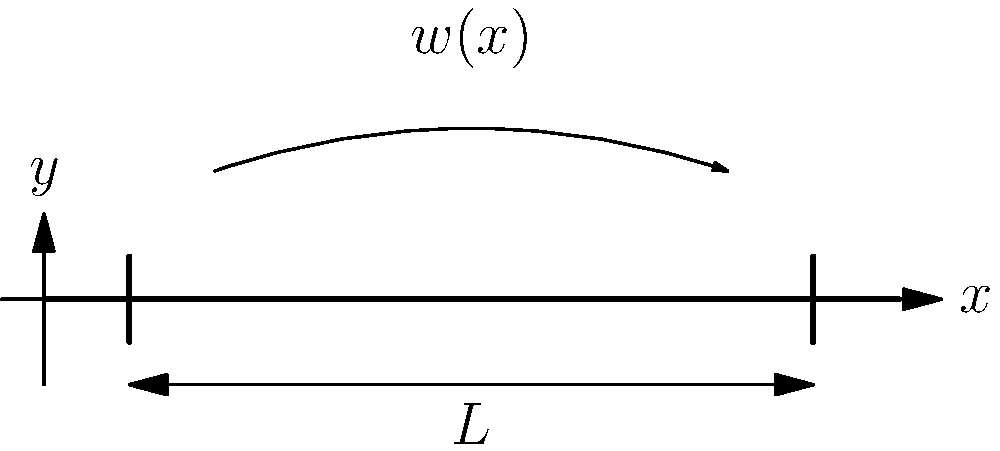A simply supported beam of length $L$ is subjected to a non-uniform distributed load $w(x)$ as shown in the figure. Given that the maximum bending moment occurs at the center of the beam, derive an expression for the shear force $V(x)$ at any point $x$ along the beam in terms of $w(x)$ and $L$. How does this relate to the stress distribution in the beam? To solve this problem, we'll follow these steps:

1) First, recall the relationship between distributed load $w(x)$, shear force $V(x)$, and bending moment $M(x)$:

   $$\frac{dV}{dx} = -w(x)$$
   $$\frac{dM}{dx} = V(x)$$

2) Given that the maximum bending moment occurs at the center of the beam, we know that the shear force at $x = L/2$ must be zero:

   $$V(L/2) = 0$$

3) We can express the shear force at any point $x$ as the integral of the distributed load from that point to the center of the beam:

   $$V(x) = \int_{x}^{L/2} w(t) dt$$

4) This expression gives us the shear force distribution along the beam.

5) The bending moment can then be found by integrating the shear force:

   $$M(x) = \int_{0}^{x} V(t) dt$$

6) The stress distribution in the beam is directly related to the bending moment. For a beam with rectangular cross-section, the maximum normal stress due to bending is:

   $$\sigma_{max} = \frac{M(x)y_{max}}{I}$$

   where $y_{max}$ is the distance from the neutral axis to the outer fiber, and $I$ is the moment of inertia of the cross-section.

7) Therefore, the stress distribution follows the shape of the bending moment diagram, with maximum stress occurring where the bending moment is maximum (at the center of the beam in this case).

This analysis shows how the non-uniform load affects the shear force, which in turn influences the bending moment and ultimately the stress distribution in the beam.
Answer: $V(x) = \int_{x}^{L/2} w(t) dt$ 